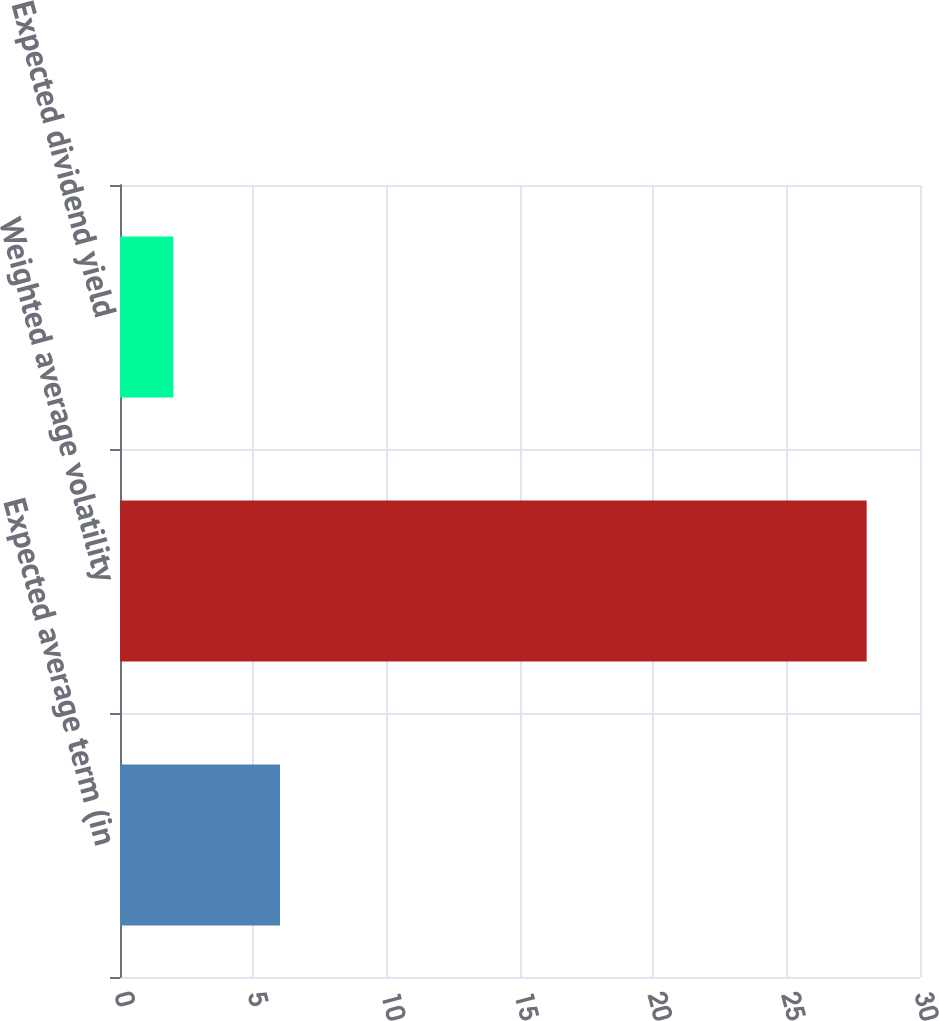Convert chart. <chart><loc_0><loc_0><loc_500><loc_500><bar_chart><fcel>Expected average term (in<fcel>Weighted average volatility<fcel>Expected dividend yield<nl><fcel>6<fcel>28<fcel>2<nl></chart> 